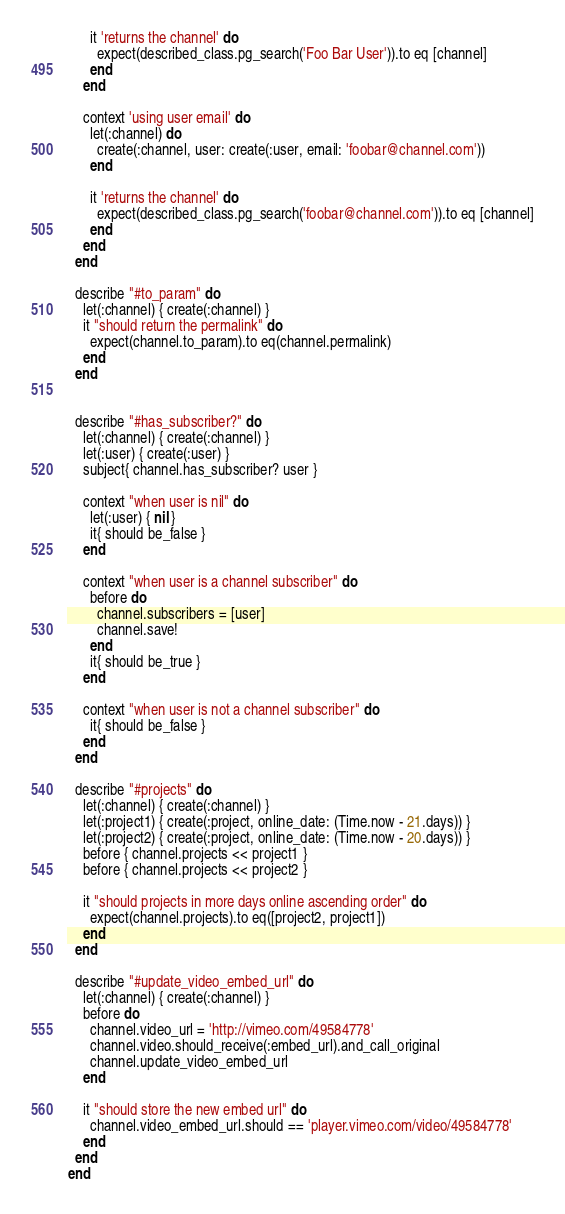<code> <loc_0><loc_0><loc_500><loc_500><_Ruby_>
      it 'returns the channel' do
        expect(described_class.pg_search('Foo Bar User')).to eq [channel]
      end
    end

    context 'using user email' do
      let(:channel) do
        create(:channel, user: create(:user, email: 'foobar@channel.com'))
      end

      it 'returns the channel' do
        expect(described_class.pg_search('foobar@channel.com')).to eq [channel]
      end
    end
  end

  describe "#to_param" do
    let(:channel) { create(:channel) }
    it "should return the permalink" do
      expect(channel.to_param).to eq(channel.permalink)
    end
  end


  describe "#has_subscriber?" do
    let(:channel) { create(:channel) }
    let(:user) { create(:user) }
    subject{ channel.has_subscriber? user }

    context "when user is nil" do
      let(:user) { nil }
      it{ should be_false }
    end

    context "when user is a channel subscriber" do
      before do
        channel.subscribers = [user]
        channel.save!
      end
      it{ should be_true }
    end

    context "when user is not a channel subscriber" do
      it{ should be_false }
    end
  end

  describe "#projects" do
    let(:channel) { create(:channel) }
    let(:project1) { create(:project, online_date: (Time.now - 21.days)) }
    let(:project2) { create(:project, online_date: (Time.now - 20.days)) }
    before { channel.projects << project1 }
    before { channel.projects << project2 }

    it "should projects in more days online ascending order" do
      expect(channel.projects).to eq([project2, project1])
    end
  end

  describe "#update_video_embed_url" do
    let(:channel) { create(:channel) }
    before do
      channel.video_url = 'http://vimeo.com/49584778'
      channel.video.should_receive(:embed_url).and_call_original
      channel.update_video_embed_url
    end

    it "should store the new embed url" do
      channel.video_embed_url.should == 'player.vimeo.com/video/49584778'
    end
  end
end
</code> 